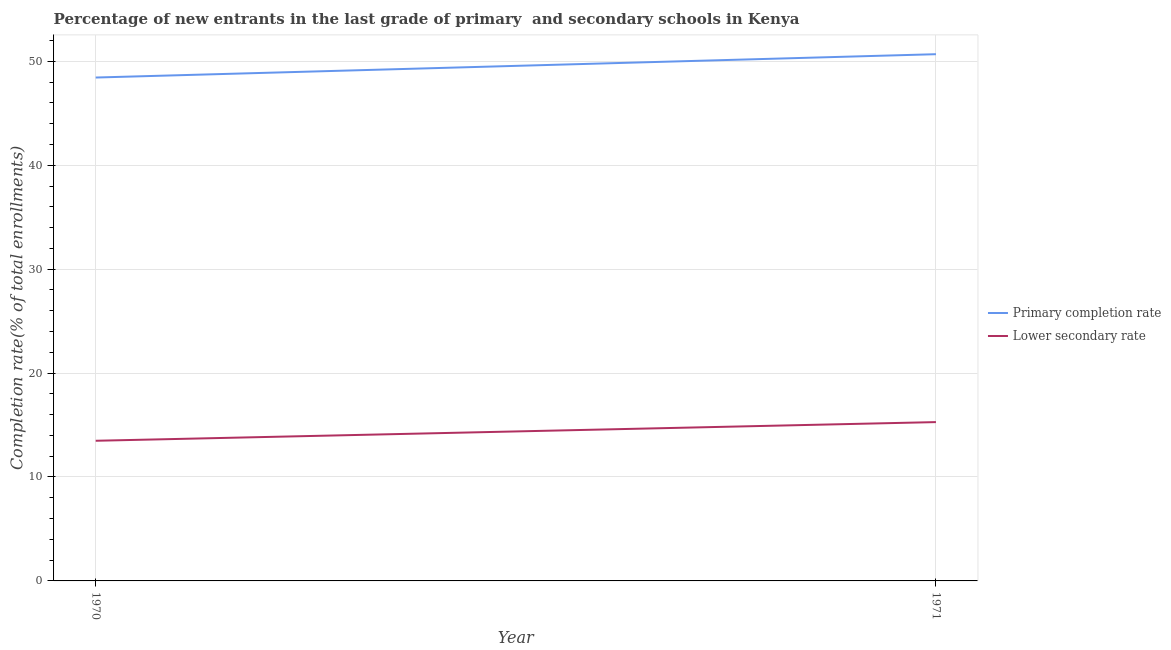Does the line corresponding to completion rate in secondary schools intersect with the line corresponding to completion rate in primary schools?
Your answer should be very brief. No. What is the completion rate in secondary schools in 1971?
Keep it short and to the point. 15.28. Across all years, what is the maximum completion rate in secondary schools?
Provide a succinct answer. 15.28. Across all years, what is the minimum completion rate in secondary schools?
Keep it short and to the point. 13.49. What is the total completion rate in secondary schools in the graph?
Offer a very short reply. 28.77. What is the difference between the completion rate in primary schools in 1970 and that in 1971?
Keep it short and to the point. -2.25. What is the difference between the completion rate in secondary schools in 1971 and the completion rate in primary schools in 1970?
Provide a succinct answer. -33.16. What is the average completion rate in primary schools per year?
Offer a terse response. 49.56. In the year 1970, what is the difference between the completion rate in secondary schools and completion rate in primary schools?
Give a very brief answer. -34.95. In how many years, is the completion rate in secondary schools greater than 28 %?
Your answer should be compact. 0. What is the ratio of the completion rate in primary schools in 1970 to that in 1971?
Give a very brief answer. 0.96. Does the completion rate in secondary schools monotonically increase over the years?
Provide a short and direct response. Yes. Is the completion rate in primary schools strictly greater than the completion rate in secondary schools over the years?
Keep it short and to the point. Yes. How many lines are there?
Make the answer very short. 2. How many years are there in the graph?
Provide a short and direct response. 2. What is the difference between two consecutive major ticks on the Y-axis?
Make the answer very short. 10. Are the values on the major ticks of Y-axis written in scientific E-notation?
Offer a terse response. No. Does the graph contain any zero values?
Ensure brevity in your answer.  No. Where does the legend appear in the graph?
Keep it short and to the point. Center right. How many legend labels are there?
Offer a very short reply. 2. How are the legend labels stacked?
Provide a short and direct response. Vertical. What is the title of the graph?
Ensure brevity in your answer.  Percentage of new entrants in the last grade of primary  and secondary schools in Kenya. Does "Domestic Liabilities" appear as one of the legend labels in the graph?
Provide a succinct answer. No. What is the label or title of the Y-axis?
Your answer should be compact. Completion rate(% of total enrollments). What is the Completion rate(% of total enrollments) in Primary completion rate in 1970?
Your answer should be compact. 48.44. What is the Completion rate(% of total enrollments) in Lower secondary rate in 1970?
Your answer should be very brief. 13.49. What is the Completion rate(% of total enrollments) of Primary completion rate in 1971?
Offer a very short reply. 50.68. What is the Completion rate(% of total enrollments) in Lower secondary rate in 1971?
Your response must be concise. 15.28. Across all years, what is the maximum Completion rate(% of total enrollments) in Primary completion rate?
Give a very brief answer. 50.68. Across all years, what is the maximum Completion rate(% of total enrollments) in Lower secondary rate?
Offer a very short reply. 15.28. Across all years, what is the minimum Completion rate(% of total enrollments) of Primary completion rate?
Keep it short and to the point. 48.44. Across all years, what is the minimum Completion rate(% of total enrollments) of Lower secondary rate?
Provide a short and direct response. 13.49. What is the total Completion rate(% of total enrollments) in Primary completion rate in the graph?
Your response must be concise. 99.12. What is the total Completion rate(% of total enrollments) of Lower secondary rate in the graph?
Provide a short and direct response. 28.77. What is the difference between the Completion rate(% of total enrollments) of Primary completion rate in 1970 and that in 1971?
Give a very brief answer. -2.25. What is the difference between the Completion rate(% of total enrollments) of Lower secondary rate in 1970 and that in 1971?
Provide a succinct answer. -1.8. What is the difference between the Completion rate(% of total enrollments) in Primary completion rate in 1970 and the Completion rate(% of total enrollments) in Lower secondary rate in 1971?
Provide a short and direct response. 33.16. What is the average Completion rate(% of total enrollments) in Primary completion rate per year?
Provide a succinct answer. 49.56. What is the average Completion rate(% of total enrollments) in Lower secondary rate per year?
Your answer should be compact. 14.38. In the year 1970, what is the difference between the Completion rate(% of total enrollments) of Primary completion rate and Completion rate(% of total enrollments) of Lower secondary rate?
Provide a short and direct response. 34.95. In the year 1971, what is the difference between the Completion rate(% of total enrollments) of Primary completion rate and Completion rate(% of total enrollments) of Lower secondary rate?
Your answer should be compact. 35.4. What is the ratio of the Completion rate(% of total enrollments) in Primary completion rate in 1970 to that in 1971?
Provide a succinct answer. 0.96. What is the ratio of the Completion rate(% of total enrollments) in Lower secondary rate in 1970 to that in 1971?
Your answer should be very brief. 0.88. What is the difference between the highest and the second highest Completion rate(% of total enrollments) of Primary completion rate?
Provide a short and direct response. 2.25. What is the difference between the highest and the second highest Completion rate(% of total enrollments) in Lower secondary rate?
Make the answer very short. 1.8. What is the difference between the highest and the lowest Completion rate(% of total enrollments) of Primary completion rate?
Give a very brief answer. 2.25. What is the difference between the highest and the lowest Completion rate(% of total enrollments) of Lower secondary rate?
Your response must be concise. 1.8. 